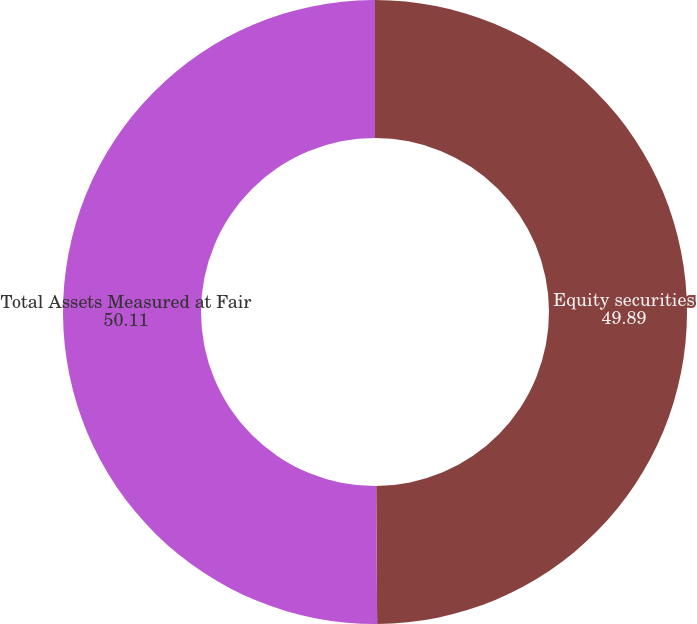Convert chart. <chart><loc_0><loc_0><loc_500><loc_500><pie_chart><fcel>Equity securities<fcel>Total Assets Measured at Fair<nl><fcel>49.89%<fcel>50.11%<nl></chart> 